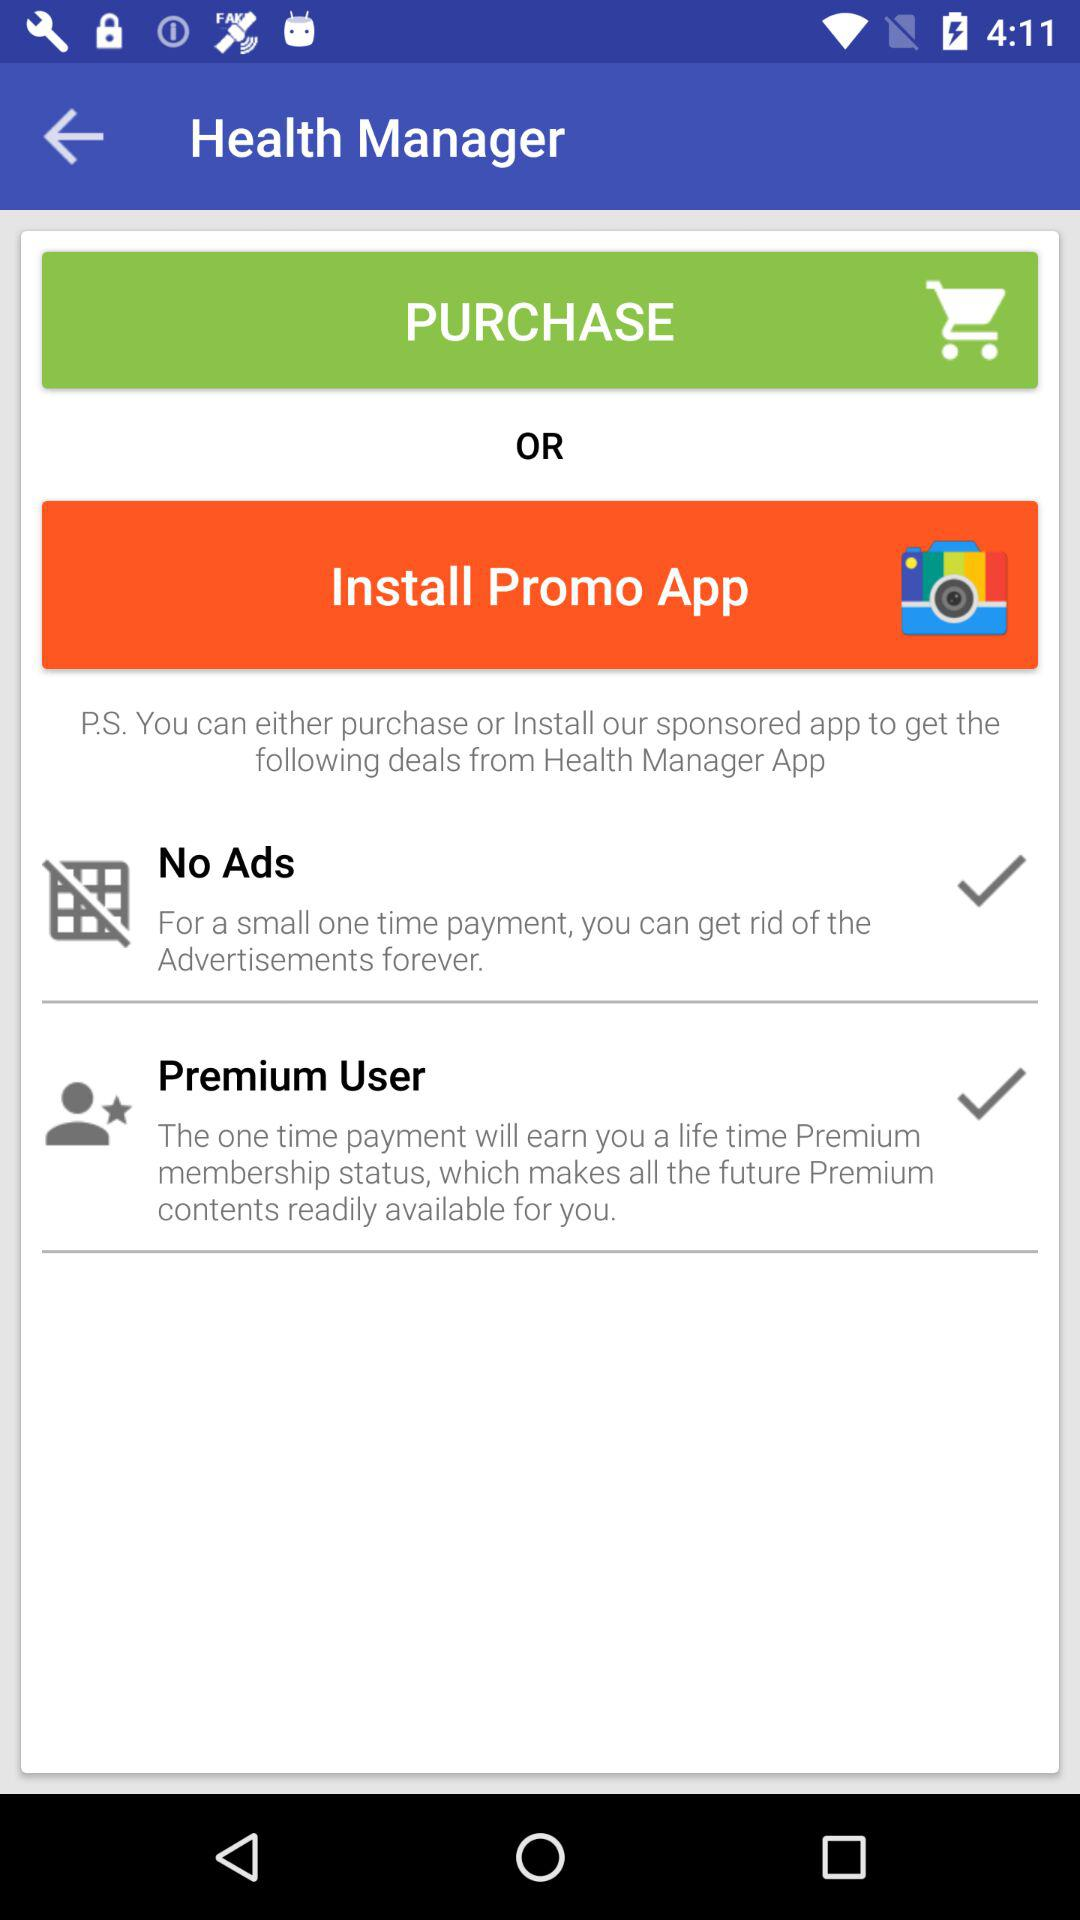How many of the deals are free?
Answer the question using a single word or phrase. 1 